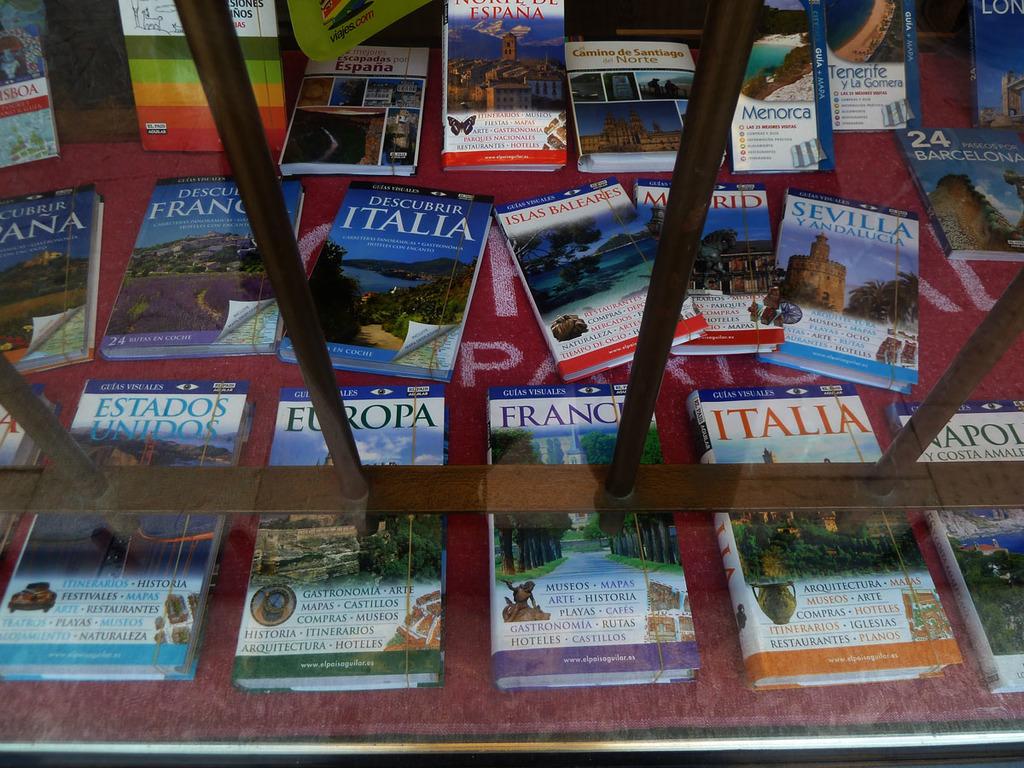What countries' guide books are in the picture?
Your response must be concise. Italia, france. What do all these books have in common/?
Ensure brevity in your answer.  Guias visuales. 